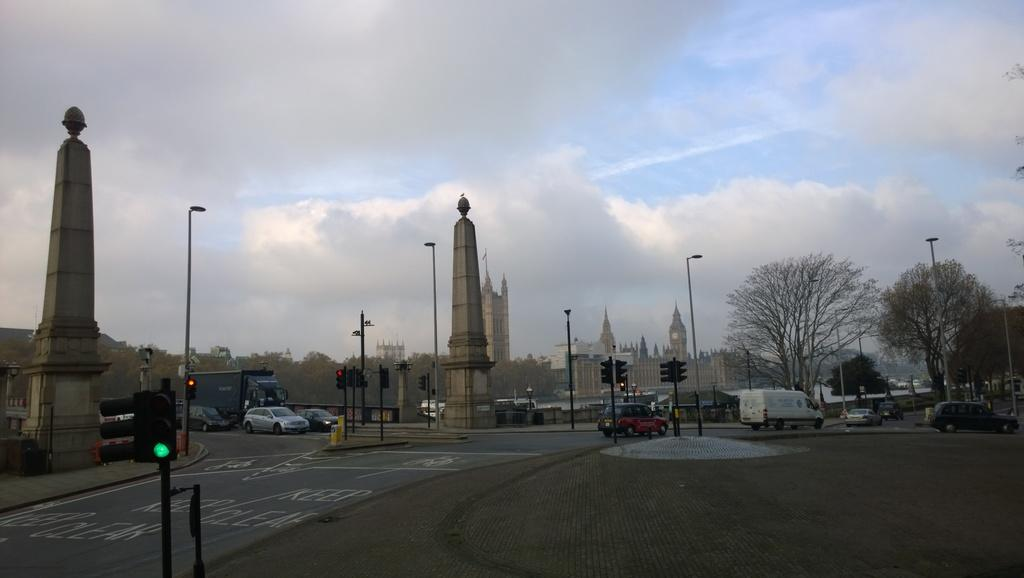What can be seen on the road in the image? There are vehicles on the road in the image. What structures are present in the image? There are poles, trees, buildings, and traffic signals in the image. What is visible in the background of the image? The sky is visible in the background of the image, and clouds are present in the sky. What type of breakfast is being served to the family in the image? There is no reference to a family or breakfast in the image; it features vehicles on the road, poles, trees, buildings, traffic signals, and a sky with clouds. 